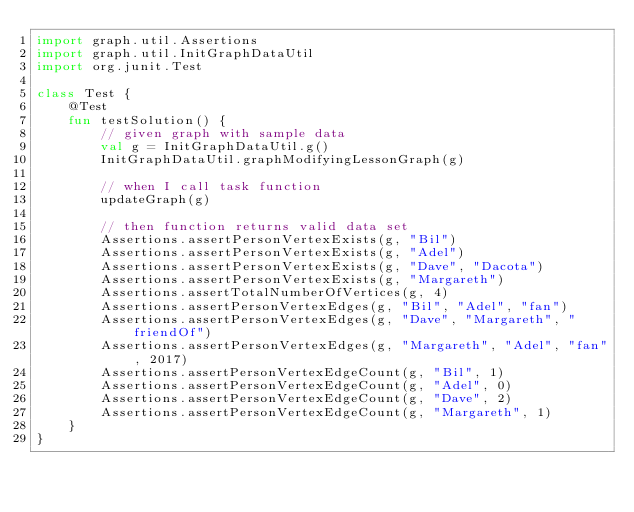<code> <loc_0><loc_0><loc_500><loc_500><_Kotlin_>import graph.util.Assertions
import graph.util.InitGraphDataUtil
import org.junit.Test

class Test {
    @Test
    fun testSolution() {
        // given graph with sample data
        val g = InitGraphDataUtil.g()
        InitGraphDataUtil.graphModifyingLessonGraph(g)

        // when I call task function
        updateGraph(g)

        // then function returns valid data set
        Assertions.assertPersonVertexExists(g, "Bil")
        Assertions.assertPersonVertexExists(g, "Adel")
        Assertions.assertPersonVertexExists(g, "Dave", "Dacota")
        Assertions.assertPersonVertexExists(g, "Margareth")
        Assertions.assertTotalNumberOfVertices(g, 4)
        Assertions.assertPersonVertexEdges(g, "Bil", "Adel", "fan")
        Assertions.assertPersonVertexEdges(g, "Dave", "Margareth", "friendOf")
        Assertions.assertPersonVertexEdges(g, "Margareth", "Adel", "fan", 2017)
        Assertions.assertPersonVertexEdgeCount(g, "Bil", 1)
        Assertions.assertPersonVertexEdgeCount(g, "Adel", 0)
        Assertions.assertPersonVertexEdgeCount(g, "Dave", 2)
        Assertions.assertPersonVertexEdgeCount(g, "Margareth", 1)
    }
}
</code> 